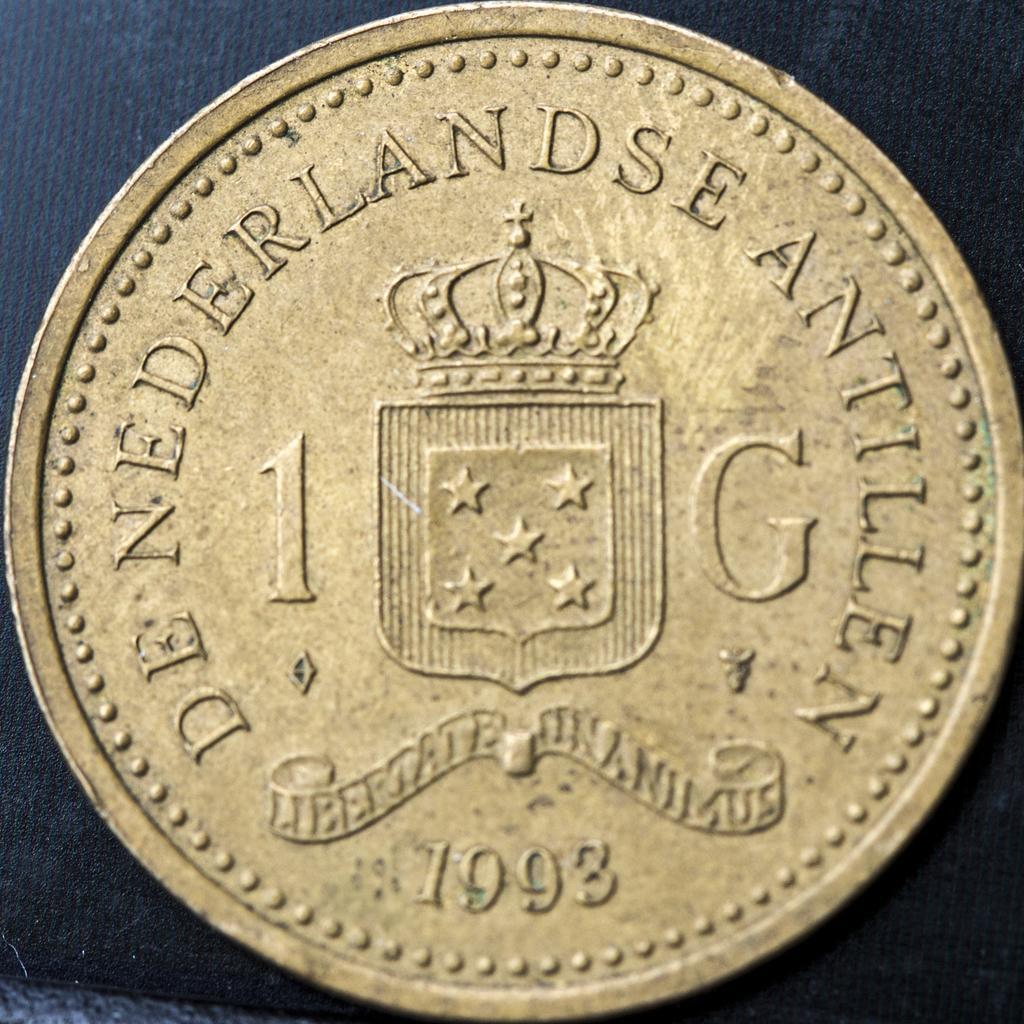<image>
Write a terse but informative summary of the picture. A clean 1993 coin from De Nederlandse Antillen. 